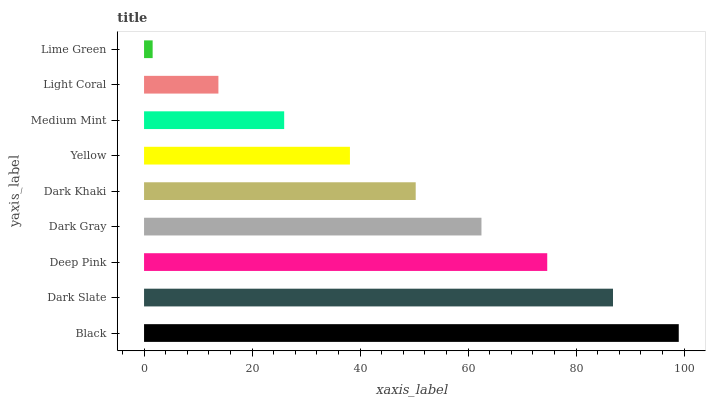Is Lime Green the minimum?
Answer yes or no. Yes. Is Black the maximum?
Answer yes or no. Yes. Is Dark Slate the minimum?
Answer yes or no. No. Is Dark Slate the maximum?
Answer yes or no. No. Is Black greater than Dark Slate?
Answer yes or no. Yes. Is Dark Slate less than Black?
Answer yes or no. Yes. Is Dark Slate greater than Black?
Answer yes or no. No. Is Black less than Dark Slate?
Answer yes or no. No. Is Dark Khaki the high median?
Answer yes or no. Yes. Is Dark Khaki the low median?
Answer yes or no. Yes. Is Medium Mint the high median?
Answer yes or no. No. Is Yellow the low median?
Answer yes or no. No. 